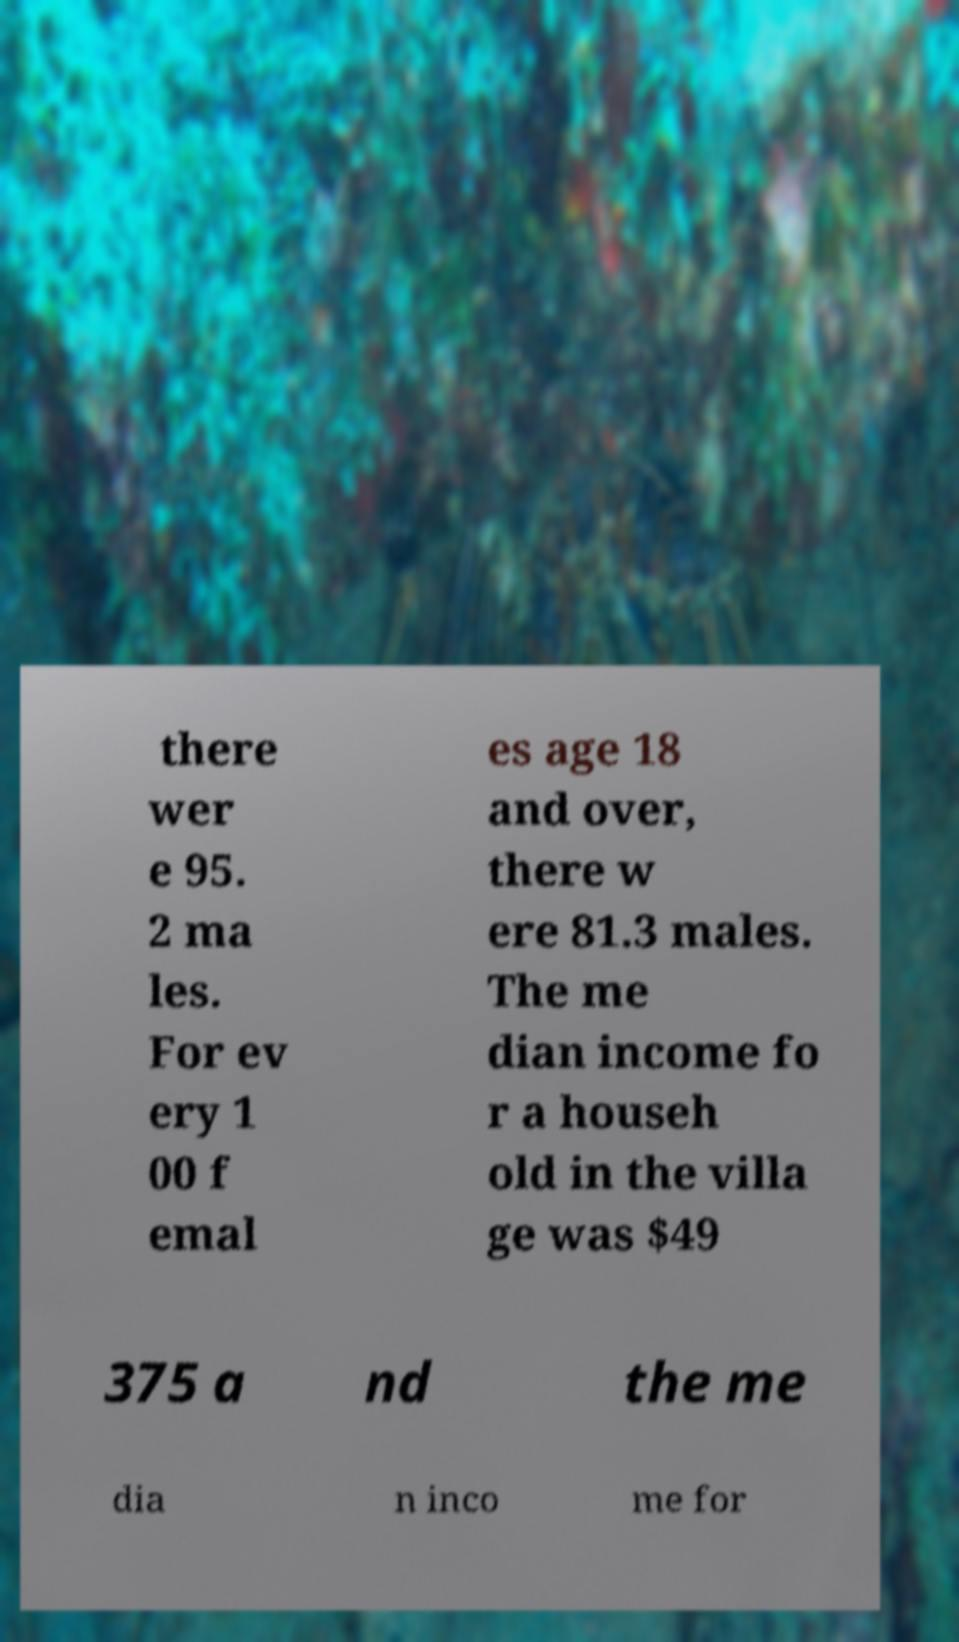For documentation purposes, I need the text within this image transcribed. Could you provide that? there wer e 95. 2 ma les. For ev ery 1 00 f emal es age 18 and over, there w ere 81.3 males. The me dian income fo r a househ old in the villa ge was $49 375 a nd the me dia n inco me for 